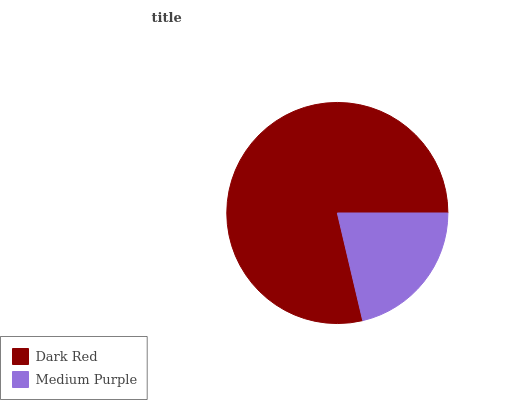Is Medium Purple the minimum?
Answer yes or no. Yes. Is Dark Red the maximum?
Answer yes or no. Yes. Is Medium Purple the maximum?
Answer yes or no. No. Is Dark Red greater than Medium Purple?
Answer yes or no. Yes. Is Medium Purple less than Dark Red?
Answer yes or no. Yes. Is Medium Purple greater than Dark Red?
Answer yes or no. No. Is Dark Red less than Medium Purple?
Answer yes or no. No. Is Dark Red the high median?
Answer yes or no. Yes. Is Medium Purple the low median?
Answer yes or no. Yes. Is Medium Purple the high median?
Answer yes or no. No. Is Dark Red the low median?
Answer yes or no. No. 